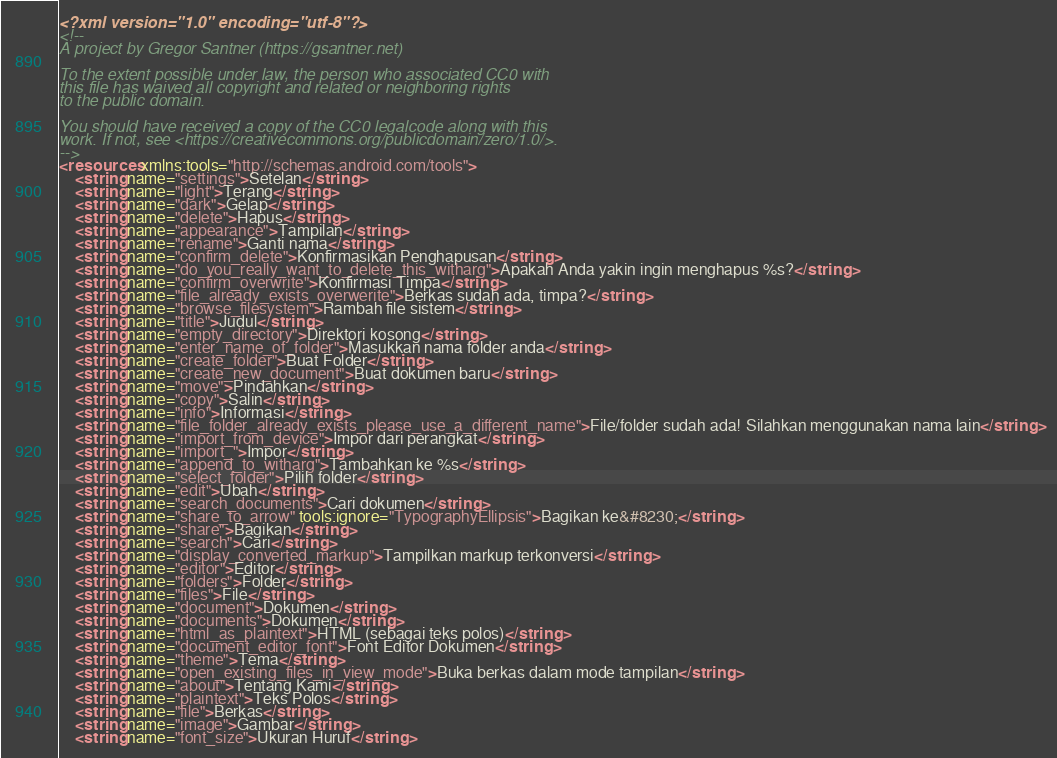Convert code to text. <code><loc_0><loc_0><loc_500><loc_500><_XML_><?xml version="1.0" encoding="utf-8"?>
<!--
A project by Gregor Santner (https://gsantner.net)

To the extent possible under law, the person who associated CC0 with
this file has waived all copyright and related or neighboring rights
to the public domain.

You should have received a copy of the CC0 legalcode along with this
work. If not, see <https://creativecommons.org/publicdomain/zero/1.0/>.
-->
<resources xmlns:tools="http://schemas.android.com/tools">
    <string name="settings">Setelan</string>
    <string name="light">Terang</string>
    <string name="dark">Gelap</string>
    <string name="delete">Hapus</string>
    <string name="appearance">Tampilan</string>
    <string name="rename">Ganti nama</string>
    <string name="confirm_delete">Konfirmasikan Penghapusan</string>
    <string name="do_you_really_want_to_delete_this_witharg">Apakah Anda yakin ingin menghapus %s?</string>
    <string name="confirm_overwrite">Konfirmasi Timpa</string>
    <string name="file_already_exists_overwerite">Berkas sudah ada, timpa?</string>
    <string name="browse_filesystem">Rambah file sistem</string>
    <string name="title">Judul</string>
    <string name="empty_directory">Direktori kosong</string>
    <string name="enter_name_of_folder">Masukkan nama folder anda</string>
    <string name="create_folder">Buat Folder</string>
    <string name="create_new_document">Buat dokumen baru</string>
    <string name="move">Pindahkan</string>
    <string name="copy">Salin</string>
    <string name="info">Informasi</string>
    <string name="file_folder_already_exists_please_use_a_different_name">File/folder sudah ada! Silahkan menggunakan nama lain</string>
    <string name="import_from_device">Impor dari perangkat</string>
    <string name="import_">Impor</string>
    <string name="append_to_witharg">Tambahkan ke %s</string>
    <string name="select_folder">Pilih folder</string>
    <string name="edit">Ubah</string>
    <string name="search_documents">Cari dokumen</string>
    <string name="share_to_arrow" tools:ignore="TypographyEllipsis">Bagikan ke&#8230;</string>
    <string name="share">Bagikan</string>
    <string name="search">Cari</string>
    <string name="display_converted_markup">Tampilkan markup terkonversi</string>
    <string name="editor">Editor</string>
    <string name="folders">Folder</string>
    <string name="files">File</string>
    <string name="document">Dokumen</string>
    <string name="documents">Dokumen</string>
    <string name="html_as_plaintext">HTML (sebagai teks polos)</string>
    <string name="document_editor_font">Font Editor Dokumen</string>
    <string name="theme">Tema</string>
    <string name="open_existing_files_in_view_mode">Buka berkas dalam mode tampilan</string>
    <string name="about">Tentang Kami</string>
    <string name="plaintext">Teks Polos</string>
    <string name="file">Berkas</string>
    <string name="image">Gambar</string>
    <string name="font_size">Ukuran Huruf</string></code> 